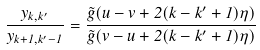Convert formula to latex. <formula><loc_0><loc_0><loc_500><loc_500>\frac { y _ { k , k ^ { \prime } } } { y _ { k + 1 , k ^ { \prime } - 1 } } = \frac { \tilde { g } ( u - v + 2 ( k - k ^ { \prime } + 1 ) \eta ) } { \tilde { g } ( v - u + 2 ( k - k ^ { \prime } + 1 ) \eta ) }</formula> 